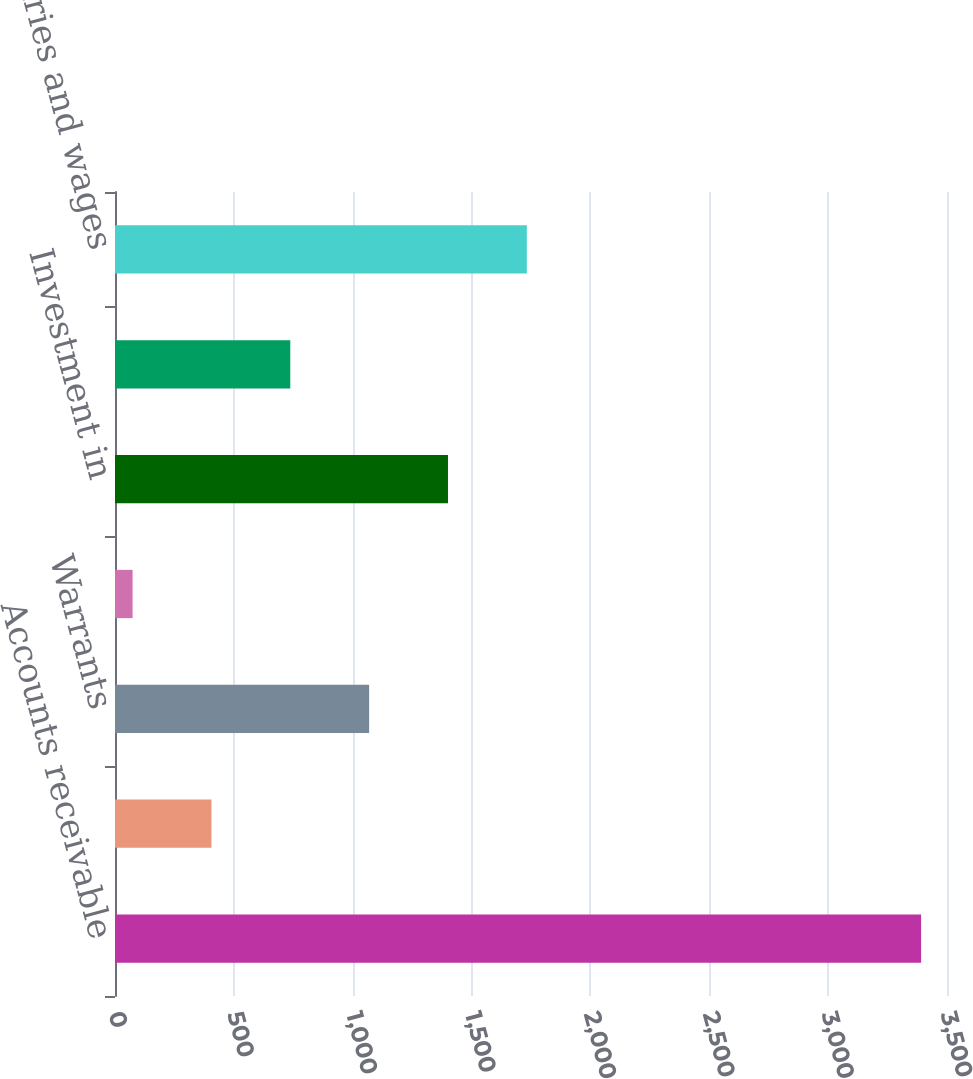Convert chart to OTSL. <chart><loc_0><loc_0><loc_500><loc_500><bar_chart><fcel>Accounts receivable<fcel>Allowance for doubtful<fcel>Warrants<fcel>Other equity method<fcel>Investment in<fcel>Other<fcel>Accrued salaries and wages<nl><fcel>3391<fcel>405.7<fcel>1069.1<fcel>74<fcel>1400.8<fcel>737.4<fcel>1732.5<nl></chart> 